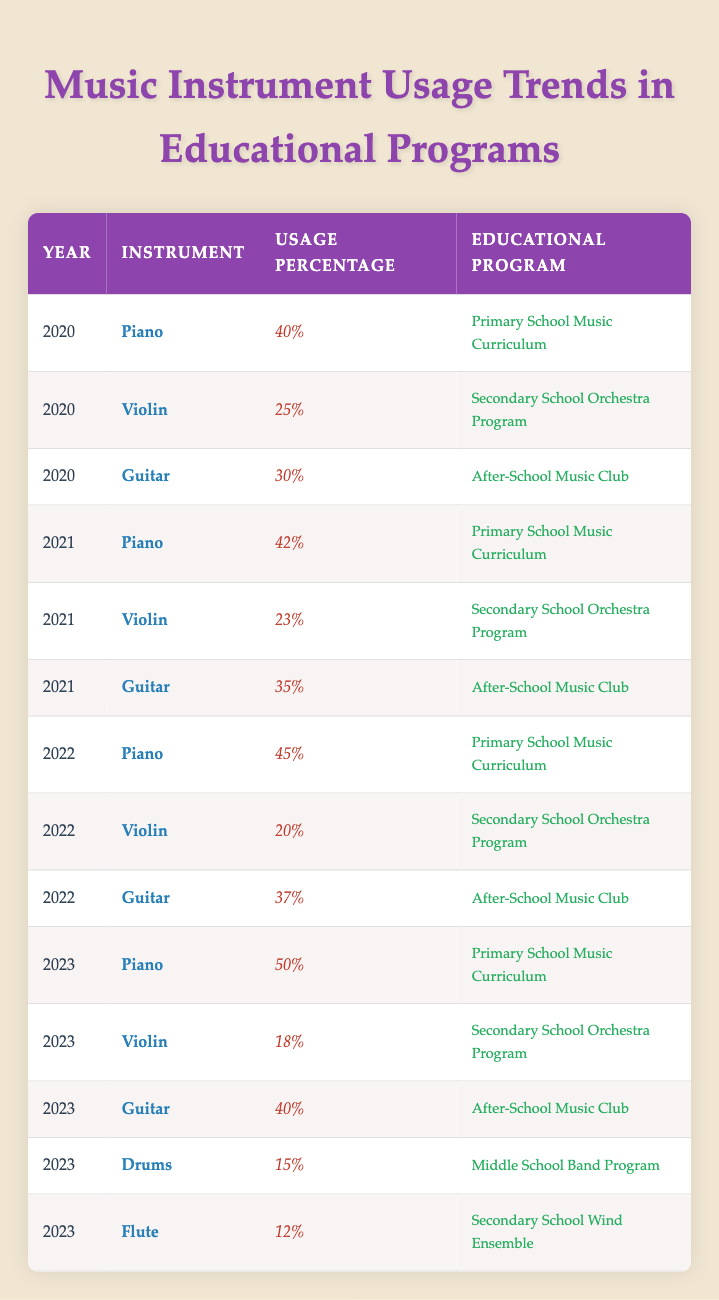What was the usage percentage of piano in the Primary School Music Curriculum in 2022? In the table for the year 2022, the usage percentage for piano in the Primary School Music Curriculum is specifically listed. By referencing that row, we can see that it is 45%.
Answer: 45% Which instrument had the highest usage percentage in 2023? To find this, we look at the usage percentages for all instruments in the year 2023. The instruments and their percentages are: Piano (50%), Violin (18%), Guitar (40%), Drums (15%), and Flute (12%). The highest among these is the piano at 50%.
Answer: Piano (50%) Is there a trend of increasing usage percentage for guitar from 2020 to 2023? To determine this, we need to examine the guitar usage percentages across the years: 2020 (30%), 2021 (35%), 2022 (37%), and 2023 (40%). Since each year shows an increase in the percentage, we conclude that there is indeed a trend of increasing usage for guitar.
Answer: Yes What was the total usage percentage of violins across the years 2021 to 2023? We will sum the usage percentages of violins in the years 2021, 2022, and 2023. The percentages are: 2021 (23%), 2022 (20%), and 2023 (18%). Adding these together gives us 23 + 20 + 18 = 61. Therefore, the total usage percentage for violins across these years is 61%.
Answer: 61% Did the piano usage percentage in the Primary School Music Curriculum exceed 40% in every year from 2021 to 2023? We need to check the percentages for piano under the Primary School Music Curriculum in each of these years. The values are: 2021 (42%), 2022 (45%), and 2023 (50%). Since all values exceed 40%, we conclude that the statement is true.
Answer: Yes In which year did the violin have the lowest usage percentage and what was that percentage? We look at the usage percentages for violins across all years: 2020 (25%), 2021 (23%), 2022 (20%), and 2023 (18%). The lowest percentage is in 2023, where it was 18%.
Answer: 2023 (18%) What is the average usage percentage of the guitar from 2020 to 2023? First, we need the guitar usage percentages for these years: 2020 (30%), 2021 (35%), 2022 (37%), and 2023 (40%). Summing these gives 30 + 35 + 37 + 40 = 142. Since there are 4 years, we divide by 4 to find the average: 142 / 4 = 35.5.
Answer: 35.5 Is the percentage of drums in the Middle School Band Program higher than that of the flute in the Secondary School Wind Ensemble in 2023? We check the percentages for both instruments in 2023. The drums have a usage percentage of 15%, while the flute has a percentage of 12%. Since 15% is higher than 12%, we can conclude that the drums do indeed have a higher percentage.
Answer: Yes 